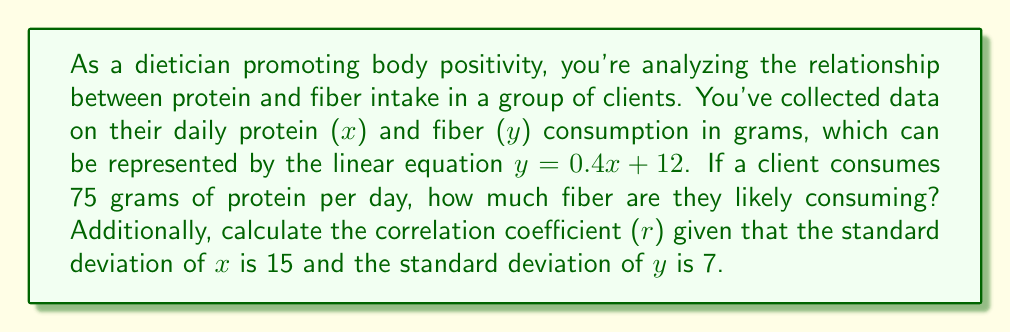Provide a solution to this math problem. To solve this problem, we'll follow these steps:

1. Calculate the fiber intake:
   Given the equation $y = 0.4x + 12$, where x is protein intake and y is fiber intake.
   Substitute x = 75 into the equation:
   $y = 0.4(75) + 12$
   $y = 30 + 12 = 42$

2. Calculate the correlation coefficient:
   The correlation coefficient (r) is given by the formula:
   $r = \frac{cov(x,y)}{s_x s_y}$

   Where $cov(x,y)$ is the covariance of x and y, and $s_x$ and $s_y$ are the standard deviations of x and y respectively.

   For a linear equation $y = mx + b$, the slope m is equal to:
   $m = r \frac{s_y}{s_x}$

   Rearranging this, we get:
   $r = m \frac{s_x}{s_y}$

   We know:
   $m = 0.4$ (slope of the given equation)
   $s_x = 15$ (standard deviation of x)
   $s_y = 7$ (standard deviation of y)

   Substituting these values:
   $r = 0.4 \frac{15}{7} = 0.4 \times \frac{15}{7} = 0.8571$
Answer: The client is likely consuming 42 grams of fiber per day.
The correlation coefficient (r) is approximately 0.86. 